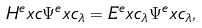Convert formula to latex. <formula><loc_0><loc_0><loc_500><loc_500>H ^ { e } x c \Psi ^ { e } x c _ { \lambda } = E ^ { e } x c _ { \lambda } \Psi ^ { e } x c _ { \lambda } ,</formula> 